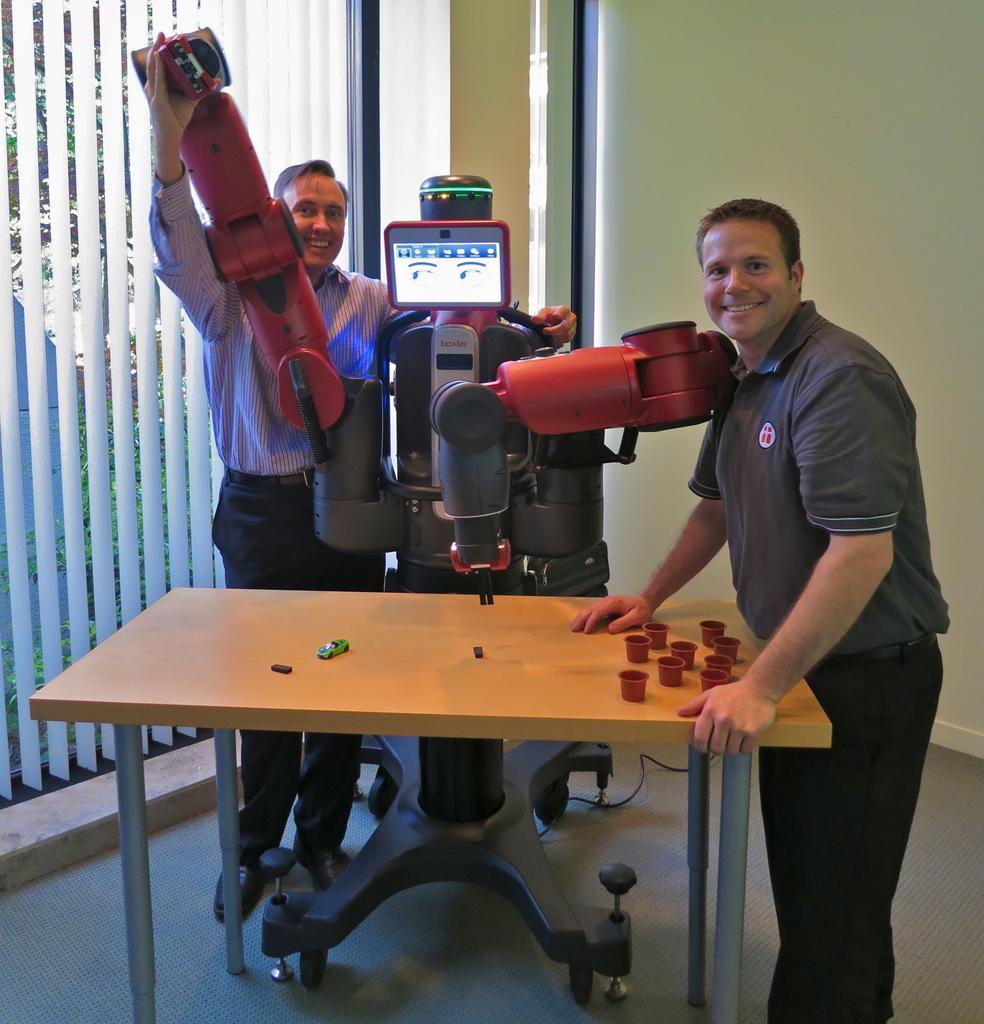Can you describe this image briefly? Here we can see 2 peoples are standing near table. In the middle, we can see some machine. On the left side, we can see window shade and glass window. Here right side, cream wall. The background, we can see few trees. And the floor here. On top of table, we can found some cups and toy. 